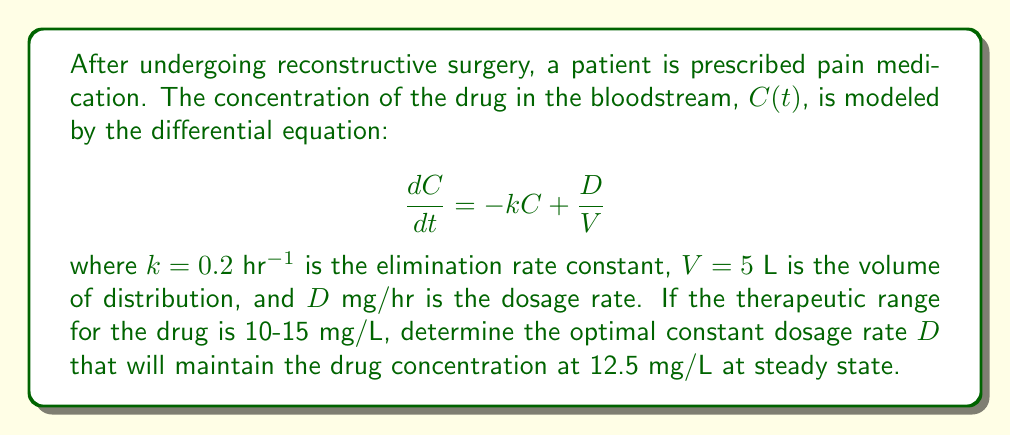Could you help me with this problem? To solve this problem, we'll follow these steps:

1) At steady state, the concentration doesn't change with time, so $\frac{dC}{dt} = 0$. We can use this to find the steady-state concentration:

   $$0 = -kC_{ss} + \frac{D}{V}$$

2) Rearrange the equation to solve for $C_{ss}$:

   $$C_{ss} = \frac{D}{kV}$$

3) We want $C_{ss}$ to be 12.5 mg/L, so we can substitute this along with the given values:

   $$12.5 = \frac{D}{(0.2)(5)}$$

4) Solve for $D$:

   $$D = 12.5 \cdot 0.2 \cdot 5 = 12.5 mg/hr$$

5) Verify that this dosage rate will keep the concentration within the therapeutic range:

   $$C_{ss} = \frac{12.5}{0.2 \cdot 5} = 12.5 mg/L$$

   This is indeed within the range of 10-15 mg/L.

Therefore, the optimal constant dosage rate is 12.5 mg/hr.
Answer: $D = 12.5$ mg/hr 